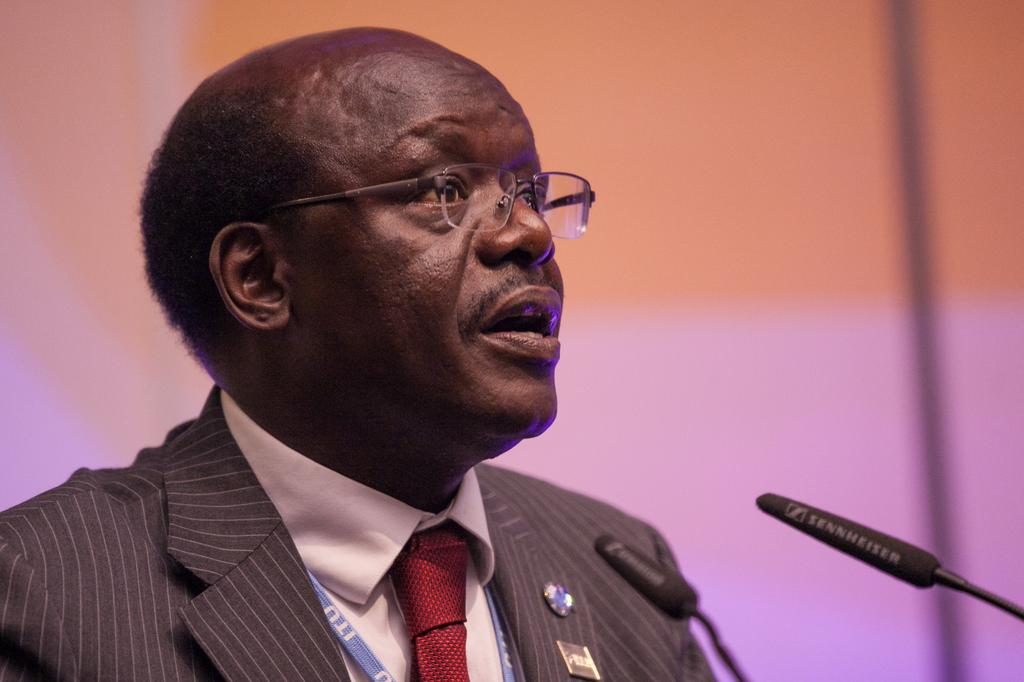Who is present in the image? There is a man in the image. What is the man wearing? The man is wearing a suit. What objects can be seen in the image besides the man? There are microphones in the image. What is visible in the background of the image? There is a wall in the background of the image. What type of chin can be seen on the hen in the image? There is no hen or chin present in the image; it features a man wearing a suit and microphones. What color is the shirt worn by the man in the image? The provided facts do not mention the color of the man's shirt, only that he is wearing a suit. 